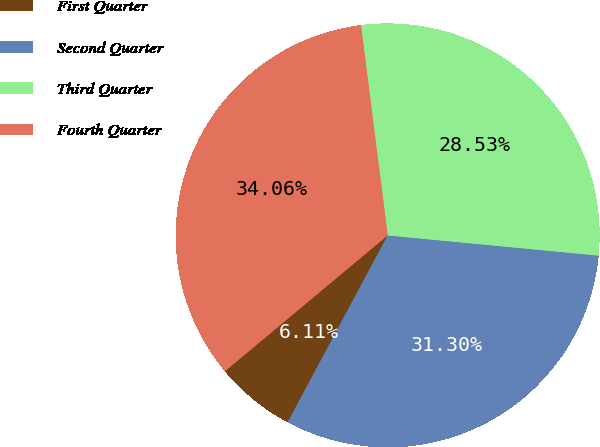Convert chart. <chart><loc_0><loc_0><loc_500><loc_500><pie_chart><fcel>First Quarter<fcel>Second Quarter<fcel>Third Quarter<fcel>Fourth Quarter<nl><fcel>6.11%<fcel>31.3%<fcel>28.53%<fcel>34.06%<nl></chart> 